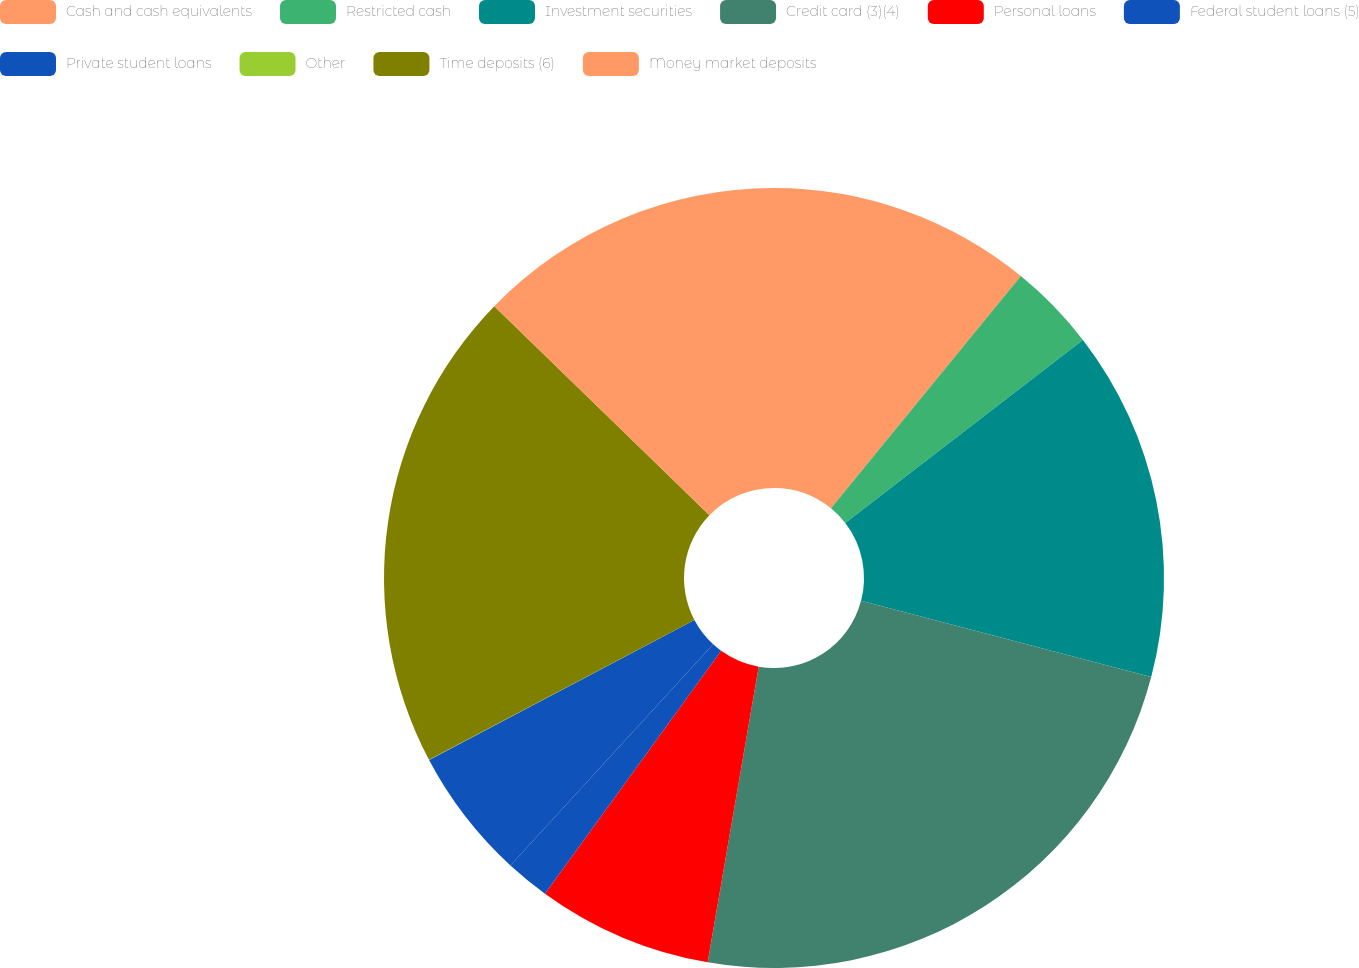Convert chart. <chart><loc_0><loc_0><loc_500><loc_500><pie_chart><fcel>Cash and cash equivalents<fcel>Restricted cash<fcel>Investment securities<fcel>Credit card (3)(4)<fcel>Personal loans<fcel>Federal student loans (5)<fcel>Private student loans<fcel>Other<fcel>Time deposits (6)<fcel>Money market deposits<nl><fcel>10.91%<fcel>3.64%<fcel>14.54%<fcel>23.63%<fcel>7.27%<fcel>1.82%<fcel>5.46%<fcel>0.01%<fcel>19.99%<fcel>12.73%<nl></chart> 